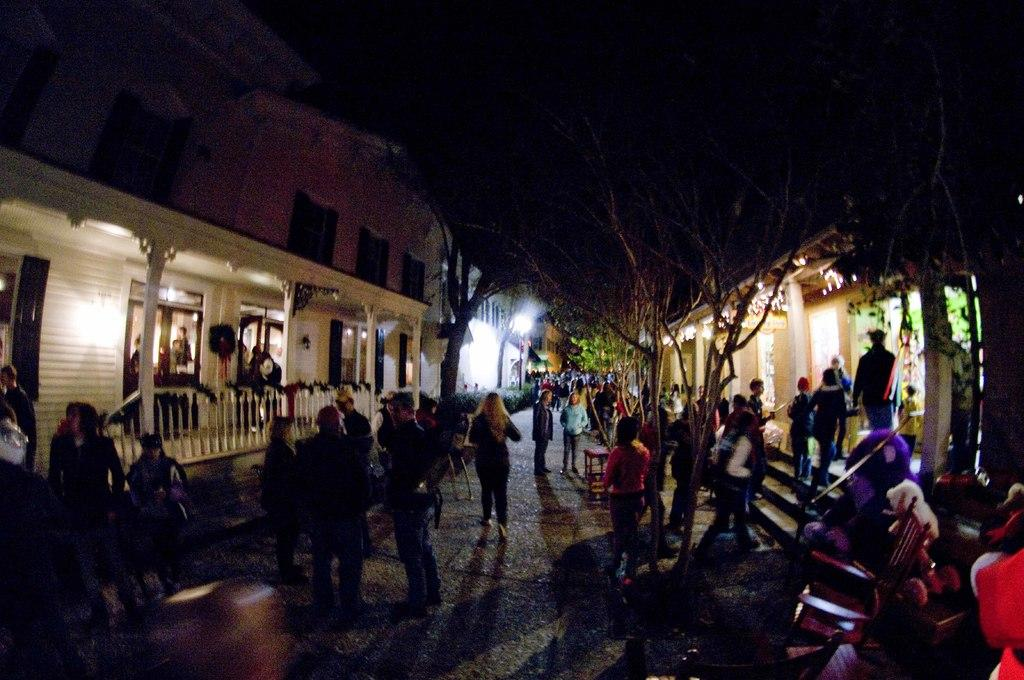Who or what is present in the image? There are people in the image. What type of natural elements can be seen in the image? There are trees in the image. What type of man-made structures are visible in the image? There are buildings on either side of the image. What type of pencil can be seen in the image? There is no pencil present in the image. What scientific discoveries are being discussed by the people in the image? There is no indication of any scientific discussions taking place in the image. 